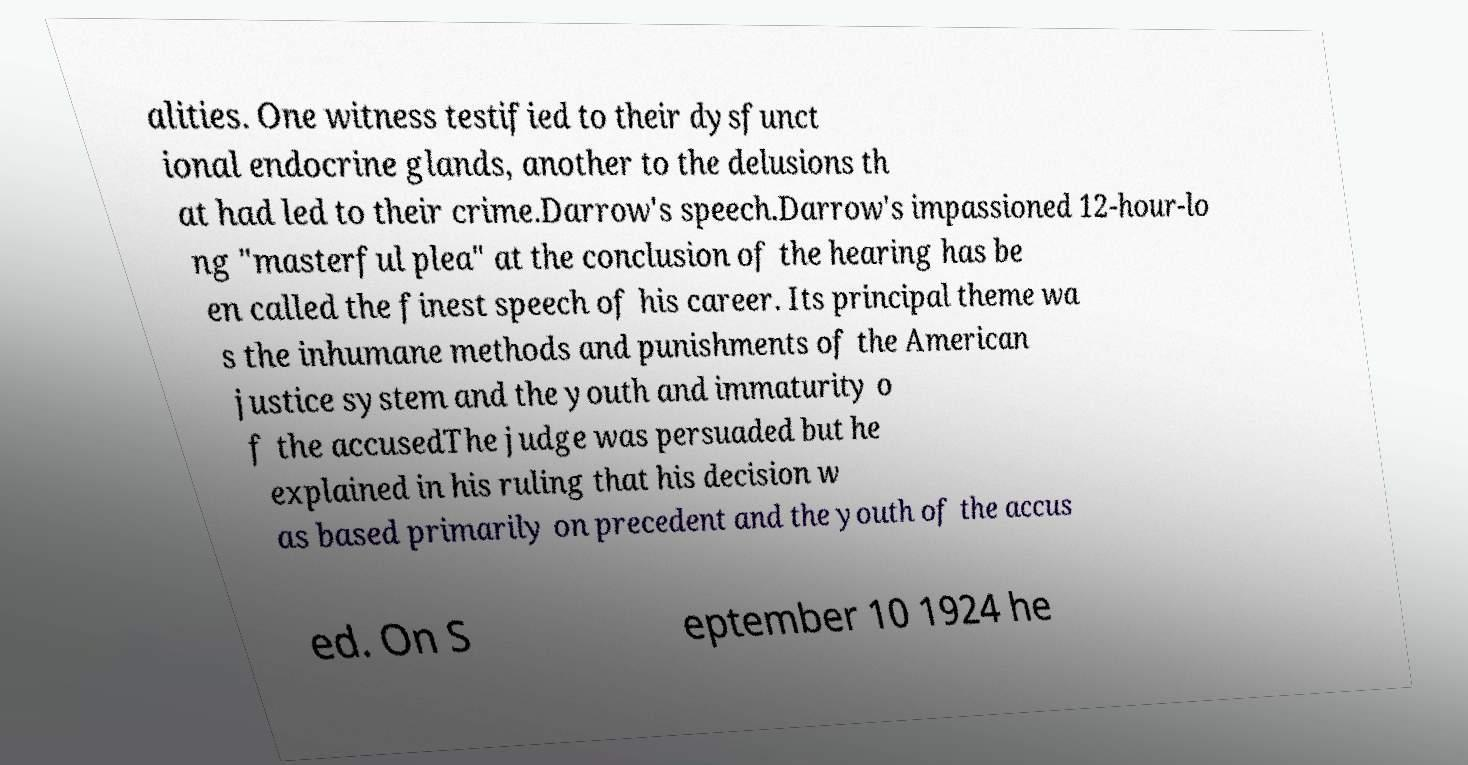Can you read and provide the text displayed in the image?This photo seems to have some interesting text. Can you extract and type it out for me? alities. One witness testified to their dysfunct ional endocrine glands, another to the delusions th at had led to their crime.Darrow's speech.Darrow's impassioned 12-hour-lo ng "masterful plea" at the conclusion of the hearing has be en called the finest speech of his career. Its principal theme wa s the inhumane methods and punishments of the American justice system and the youth and immaturity o f the accusedThe judge was persuaded but he explained in his ruling that his decision w as based primarily on precedent and the youth of the accus ed. On S eptember 10 1924 he 